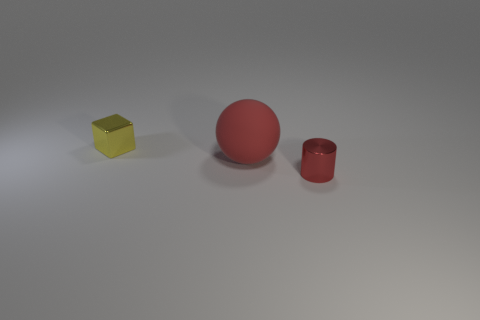Are there any other things that have the same size as the red rubber object?
Offer a very short reply. No. Is there anything else that has the same material as the sphere?
Your response must be concise. No. Does the sphere have the same material as the tiny thing that is on the right side of the small yellow metal cube?
Give a very brief answer. No. What material is the small red cylinder?
Provide a short and direct response. Metal. The small thing that is to the left of the tiny shiny thing to the right of the small metallic object that is to the left of the red metal cylinder is made of what material?
Make the answer very short. Metal. Do the red metal cylinder on the right side of the rubber object and the red rubber object that is behind the cylinder have the same size?
Give a very brief answer. No. What number of other things are there of the same material as the cube
Provide a succinct answer. 1. How many matte objects are either large objects or big blue objects?
Offer a terse response. 1. Are there fewer big red cylinders than yellow metal things?
Offer a very short reply. Yes. There is a red rubber ball; does it have the same size as the metallic object on the right side of the tiny metallic cube?
Your answer should be compact. No. 